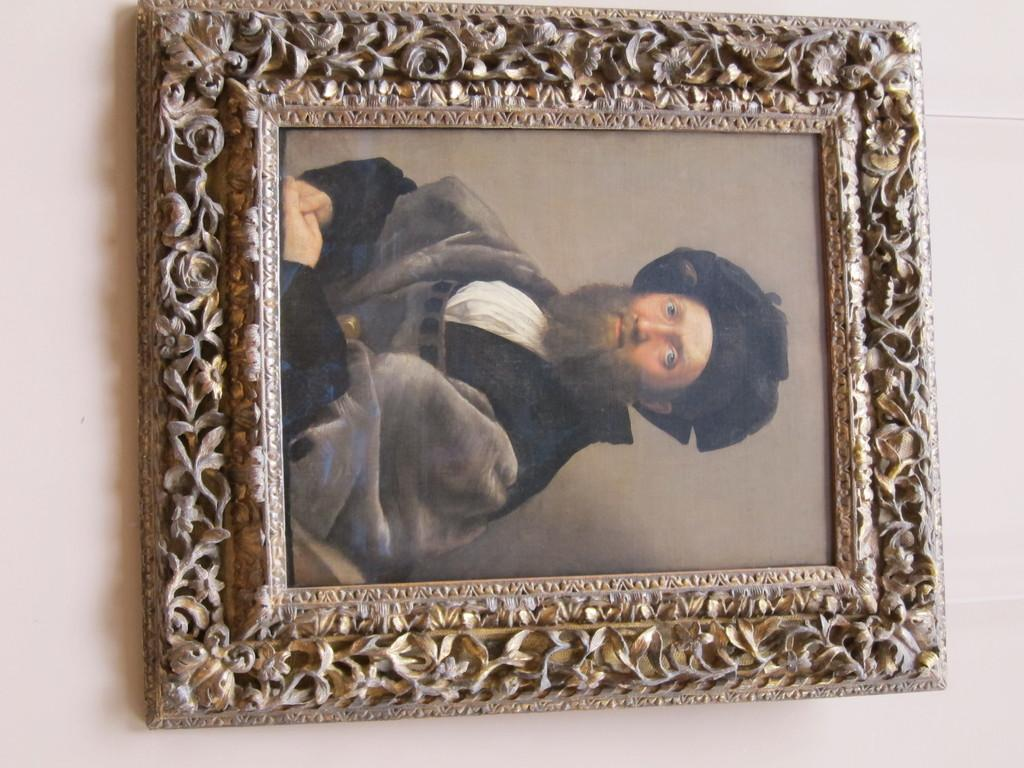What object is present in the image that typically holds a photograph? There is a photo frame in the image. What is inside the photo frame? The photo frame contains a photograph. Can you describe the person in the photograph? The person in the photograph is wearing a black and white colored dress. What is the color of the background in the photograph? The background of the photograph is light pink in color. Reasoning: Let's think step by breaking down the conversation step by step. We start by identifying the main object in the image, which is the photo frame. Then, we describe what is inside the photo frame, which is a photograph. Next, we provide details about the person in the photograph, such as their clothing and the color of the background. Each question is designed to elicit a specific detail about the image that is known from the provided facts. Absurd Question/Answer: What type of lumber is being used to support the photo frame in the image? There is no lumber present in the image; the photo frame is likely supported by a table or shelf. How many clovers can be seen growing around the photo frame in the image? There are no clovers present in the image; the focus is on the photo frame and the photograph inside it. What type of lumber is being used to support the photo frame in the image? There is no lumber present in the image; the photo frame is likely supported by a table or shelf. How many clovers can be seen growing around the photo frame in the image? There are no clovers present in the image; the focus is on the photo frame and the photograph inside it. --- Facts: 1. There is a bicycle in the image. 2. The bicycle has two wheels. 3. The bicycle is red in color. 4. There is a person riding the bicycle. 5. The person is wearing a helmet. Absurd Topics: fish, ocean, boat Conversation: What is the main object in the image? There is a bicycle in the image. How many wheels does the bicycle have? The bicycle has two wheels. What is the color of the bicycle? The bicycle is red in color. Can you describe the person riding the bicycle? The person is wearing a helmet. Reasoning: Let's think step by step in order to produce the conversation. We start by identifying the main object in the image, which is the bicycle. Then, we 